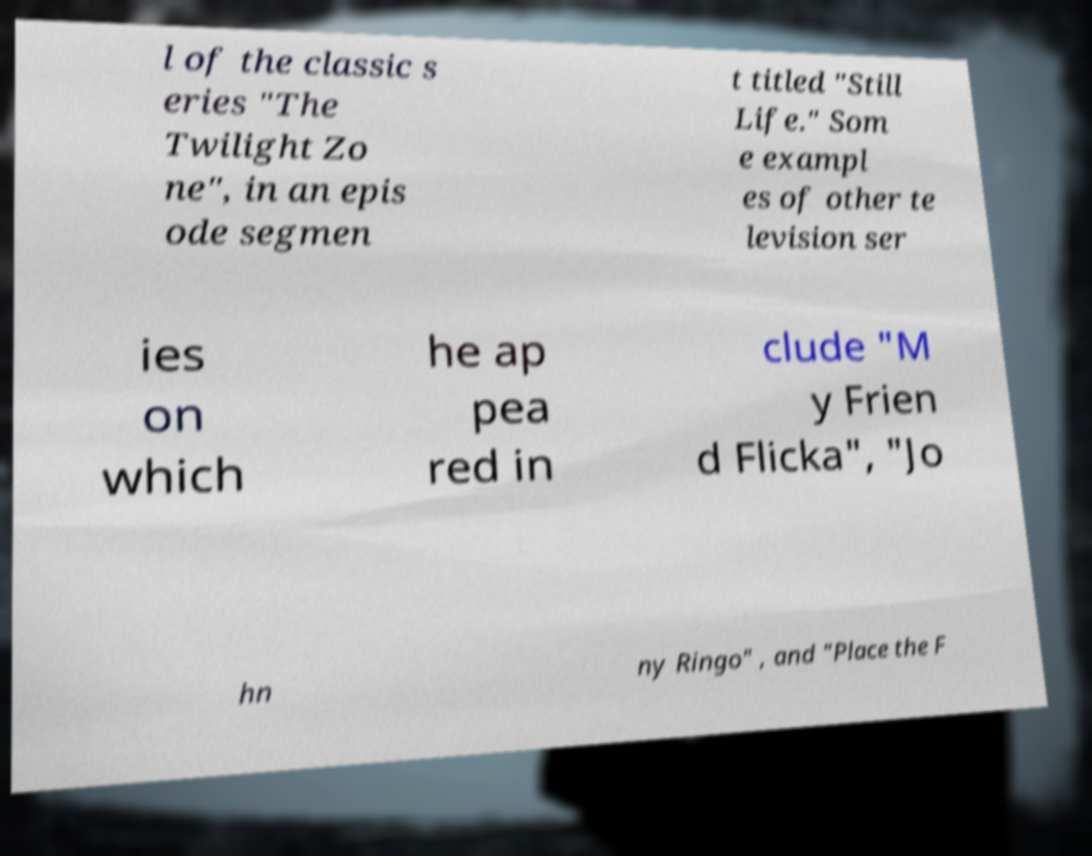What messages or text are displayed in this image? I need them in a readable, typed format. l of the classic s eries "The Twilight Zo ne", in an epis ode segmen t titled "Still Life." Som e exampl es of other te levision ser ies on which he ap pea red in clude "M y Frien d Flicka", "Jo hn ny Ringo" , and "Place the F 